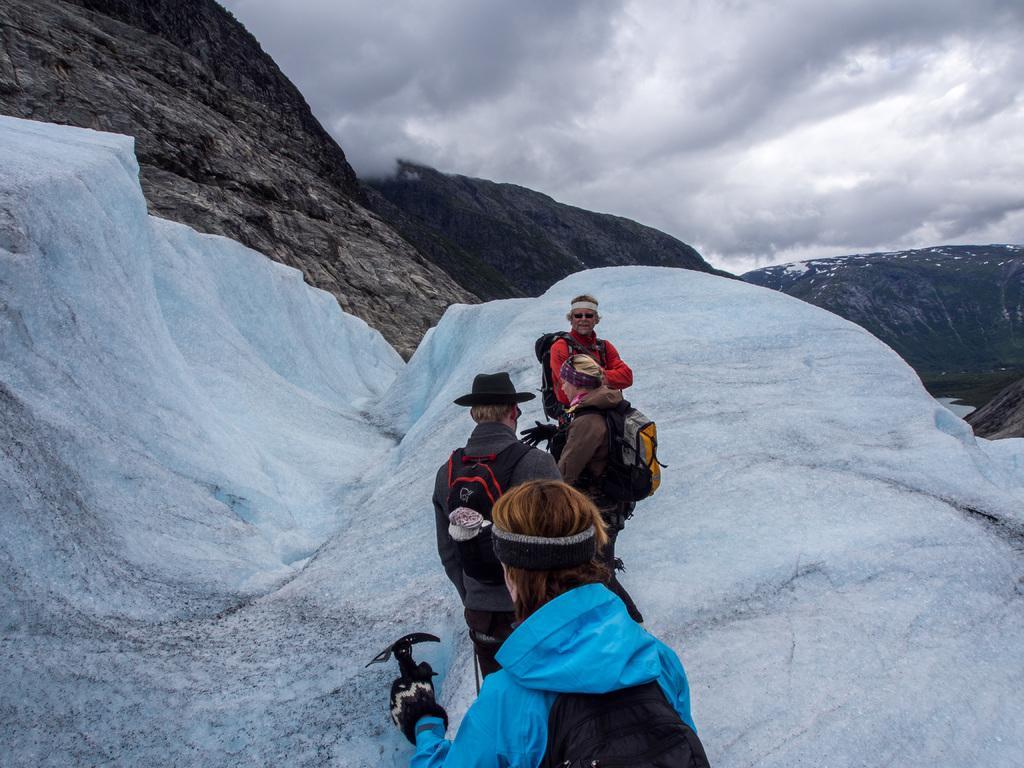In one or two sentences, can you explain what this image depicts? In this image there are few people wearing hats, gloves, bags are standing on the snowy mountain. In the background of the image there are mountains. At the top of the image there are clouds in the sky. 